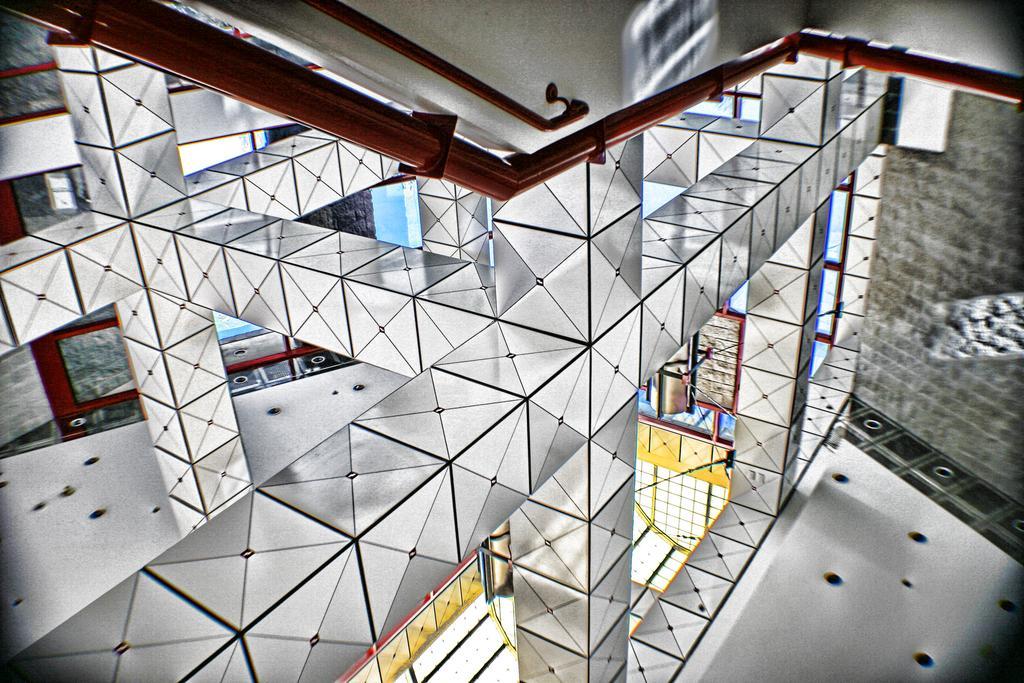In one or two sentences, can you explain what this image depicts? This is a inside view of a building , where there are mirrors, iron rods, lights, stalls. 